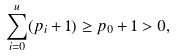<formula> <loc_0><loc_0><loc_500><loc_500>\sum _ { i = 0 } ^ { u } ( p _ { i } + 1 ) \geq p _ { 0 } + 1 > 0 ,</formula> 